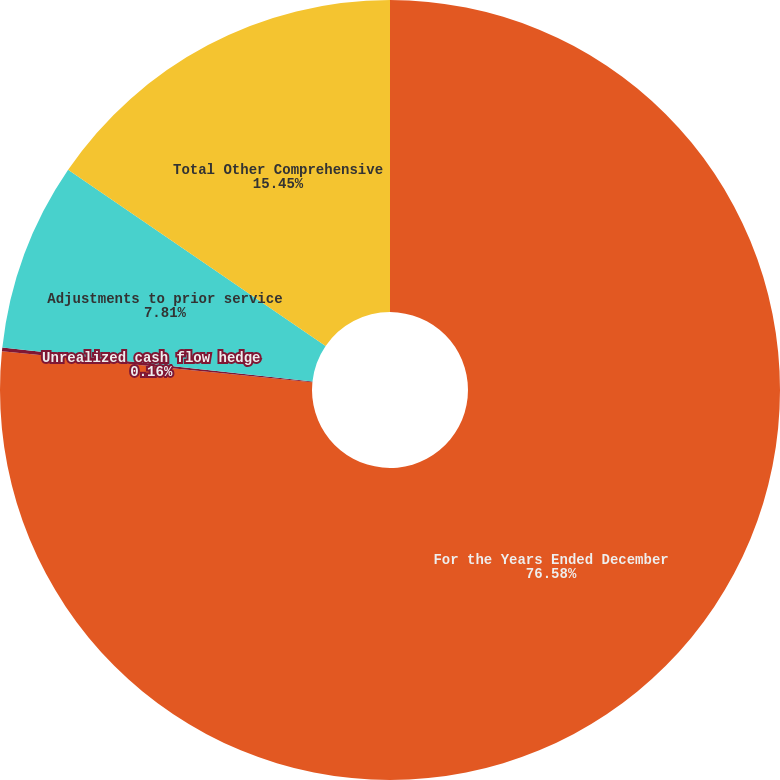Convert chart to OTSL. <chart><loc_0><loc_0><loc_500><loc_500><pie_chart><fcel>For the Years Ended December<fcel>Unrealized cash flow hedge<fcel>Adjustments to prior service<fcel>Total Other Comprehensive<nl><fcel>76.58%<fcel>0.16%<fcel>7.81%<fcel>15.45%<nl></chart> 